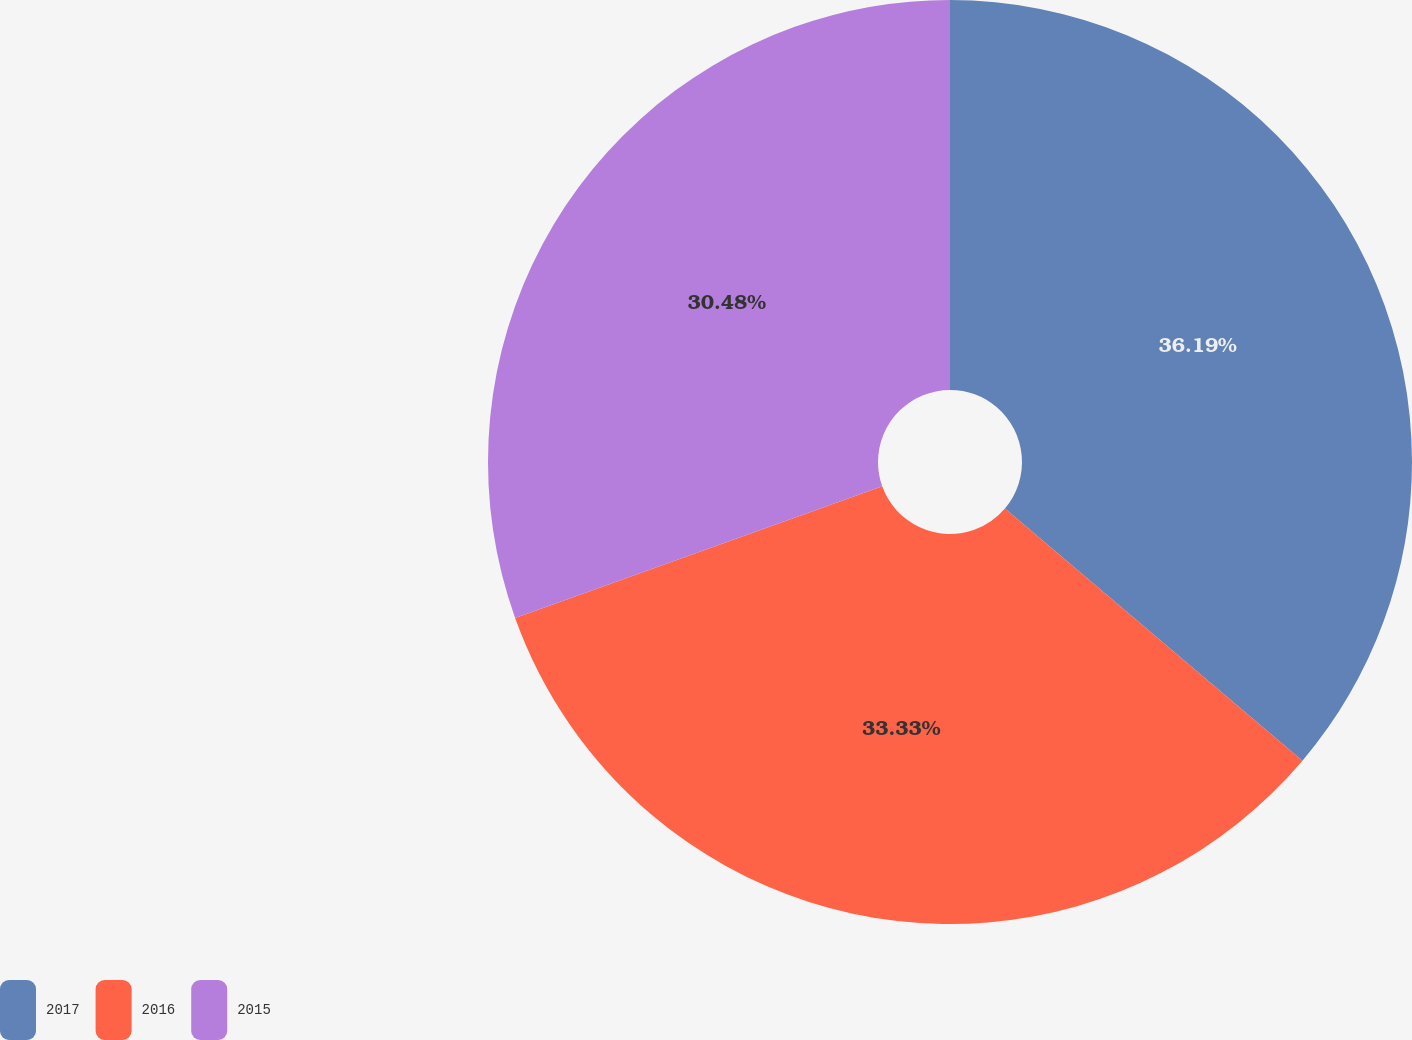<chart> <loc_0><loc_0><loc_500><loc_500><pie_chart><fcel>2017<fcel>2016<fcel>2015<nl><fcel>36.19%<fcel>33.33%<fcel>30.48%<nl></chart> 